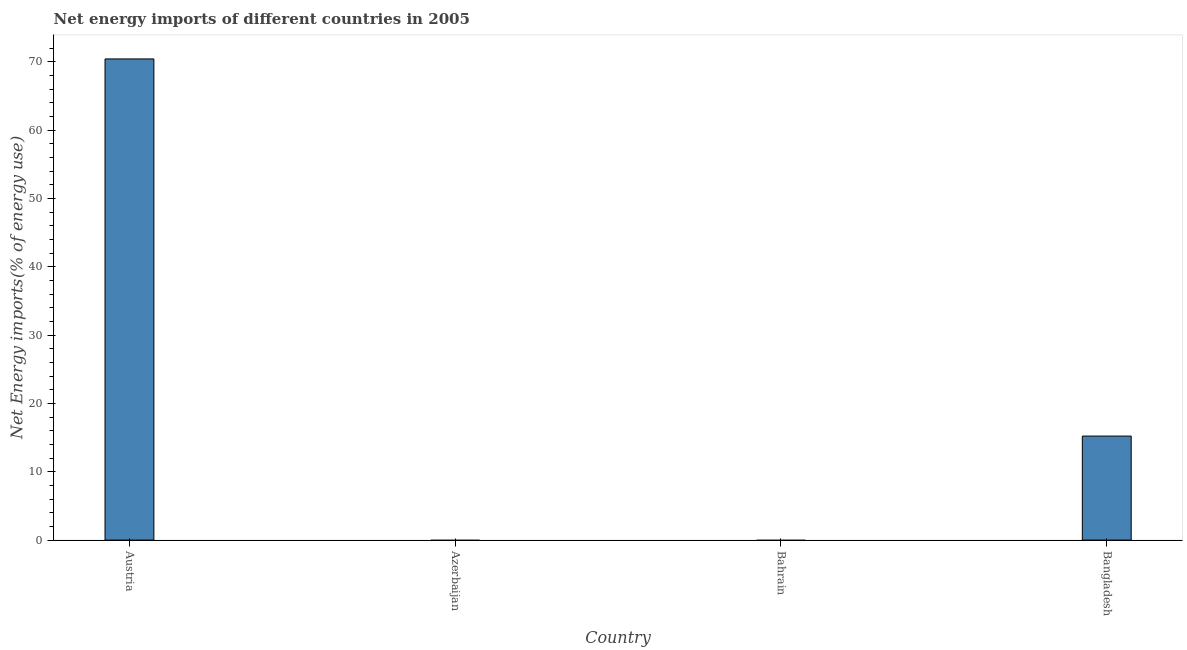What is the title of the graph?
Offer a terse response. Net energy imports of different countries in 2005. What is the label or title of the X-axis?
Provide a short and direct response. Country. What is the label or title of the Y-axis?
Offer a very short reply. Net Energy imports(% of energy use). What is the energy imports in Austria?
Provide a succinct answer. 70.42. Across all countries, what is the maximum energy imports?
Provide a short and direct response. 70.42. What is the sum of the energy imports?
Offer a very short reply. 85.64. What is the difference between the energy imports in Austria and Bangladesh?
Provide a short and direct response. 55.19. What is the average energy imports per country?
Your answer should be compact. 21.41. What is the median energy imports?
Your answer should be compact. 7.61. What is the difference between the highest and the lowest energy imports?
Ensure brevity in your answer.  70.42. How many countries are there in the graph?
Make the answer very short. 4. What is the Net Energy imports(% of energy use) of Austria?
Your response must be concise. 70.42. What is the Net Energy imports(% of energy use) of Bangladesh?
Your answer should be compact. 15.22. What is the difference between the Net Energy imports(% of energy use) in Austria and Bangladesh?
Ensure brevity in your answer.  55.19. What is the ratio of the Net Energy imports(% of energy use) in Austria to that in Bangladesh?
Give a very brief answer. 4.63. 